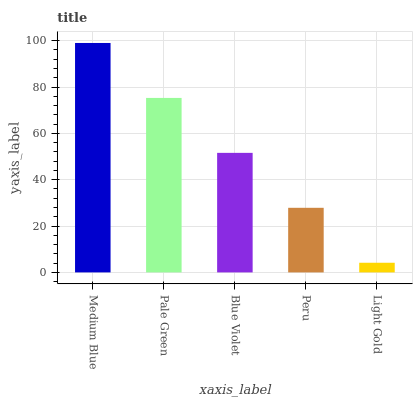Is Light Gold the minimum?
Answer yes or no. Yes. Is Medium Blue the maximum?
Answer yes or no. Yes. Is Pale Green the minimum?
Answer yes or no. No. Is Pale Green the maximum?
Answer yes or no. No. Is Medium Blue greater than Pale Green?
Answer yes or no. Yes. Is Pale Green less than Medium Blue?
Answer yes or no. Yes. Is Pale Green greater than Medium Blue?
Answer yes or no. No. Is Medium Blue less than Pale Green?
Answer yes or no. No. Is Blue Violet the high median?
Answer yes or no. Yes. Is Blue Violet the low median?
Answer yes or no. Yes. Is Peru the high median?
Answer yes or no. No. Is Pale Green the low median?
Answer yes or no. No. 